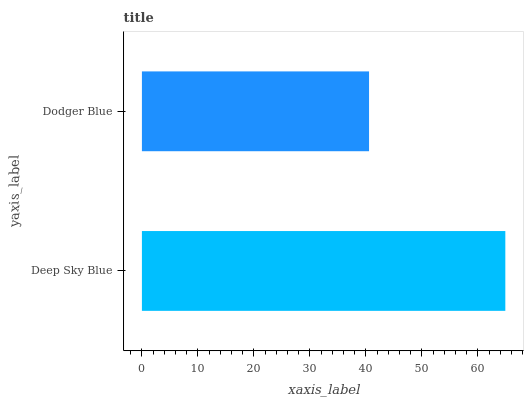Is Dodger Blue the minimum?
Answer yes or no. Yes. Is Deep Sky Blue the maximum?
Answer yes or no. Yes. Is Dodger Blue the maximum?
Answer yes or no. No. Is Deep Sky Blue greater than Dodger Blue?
Answer yes or no. Yes. Is Dodger Blue less than Deep Sky Blue?
Answer yes or no. Yes. Is Dodger Blue greater than Deep Sky Blue?
Answer yes or no. No. Is Deep Sky Blue less than Dodger Blue?
Answer yes or no. No. Is Deep Sky Blue the high median?
Answer yes or no. Yes. Is Dodger Blue the low median?
Answer yes or no. Yes. Is Dodger Blue the high median?
Answer yes or no. No. Is Deep Sky Blue the low median?
Answer yes or no. No. 